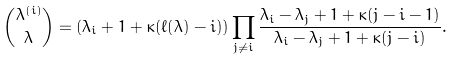<formula> <loc_0><loc_0><loc_500><loc_500>\binom { \lambda ^ { ( i ) } } { \lambda } = ( \lambda _ { i } + 1 + \kappa ( \ell ( \lambda ) - i ) ) \prod _ { j \neq i } \frac { \lambda _ { i } - \lambda _ { j } + 1 + \kappa ( j - i - 1 ) } { \lambda _ { i } - \lambda _ { j } + 1 + \kappa ( j - i ) } .</formula> 